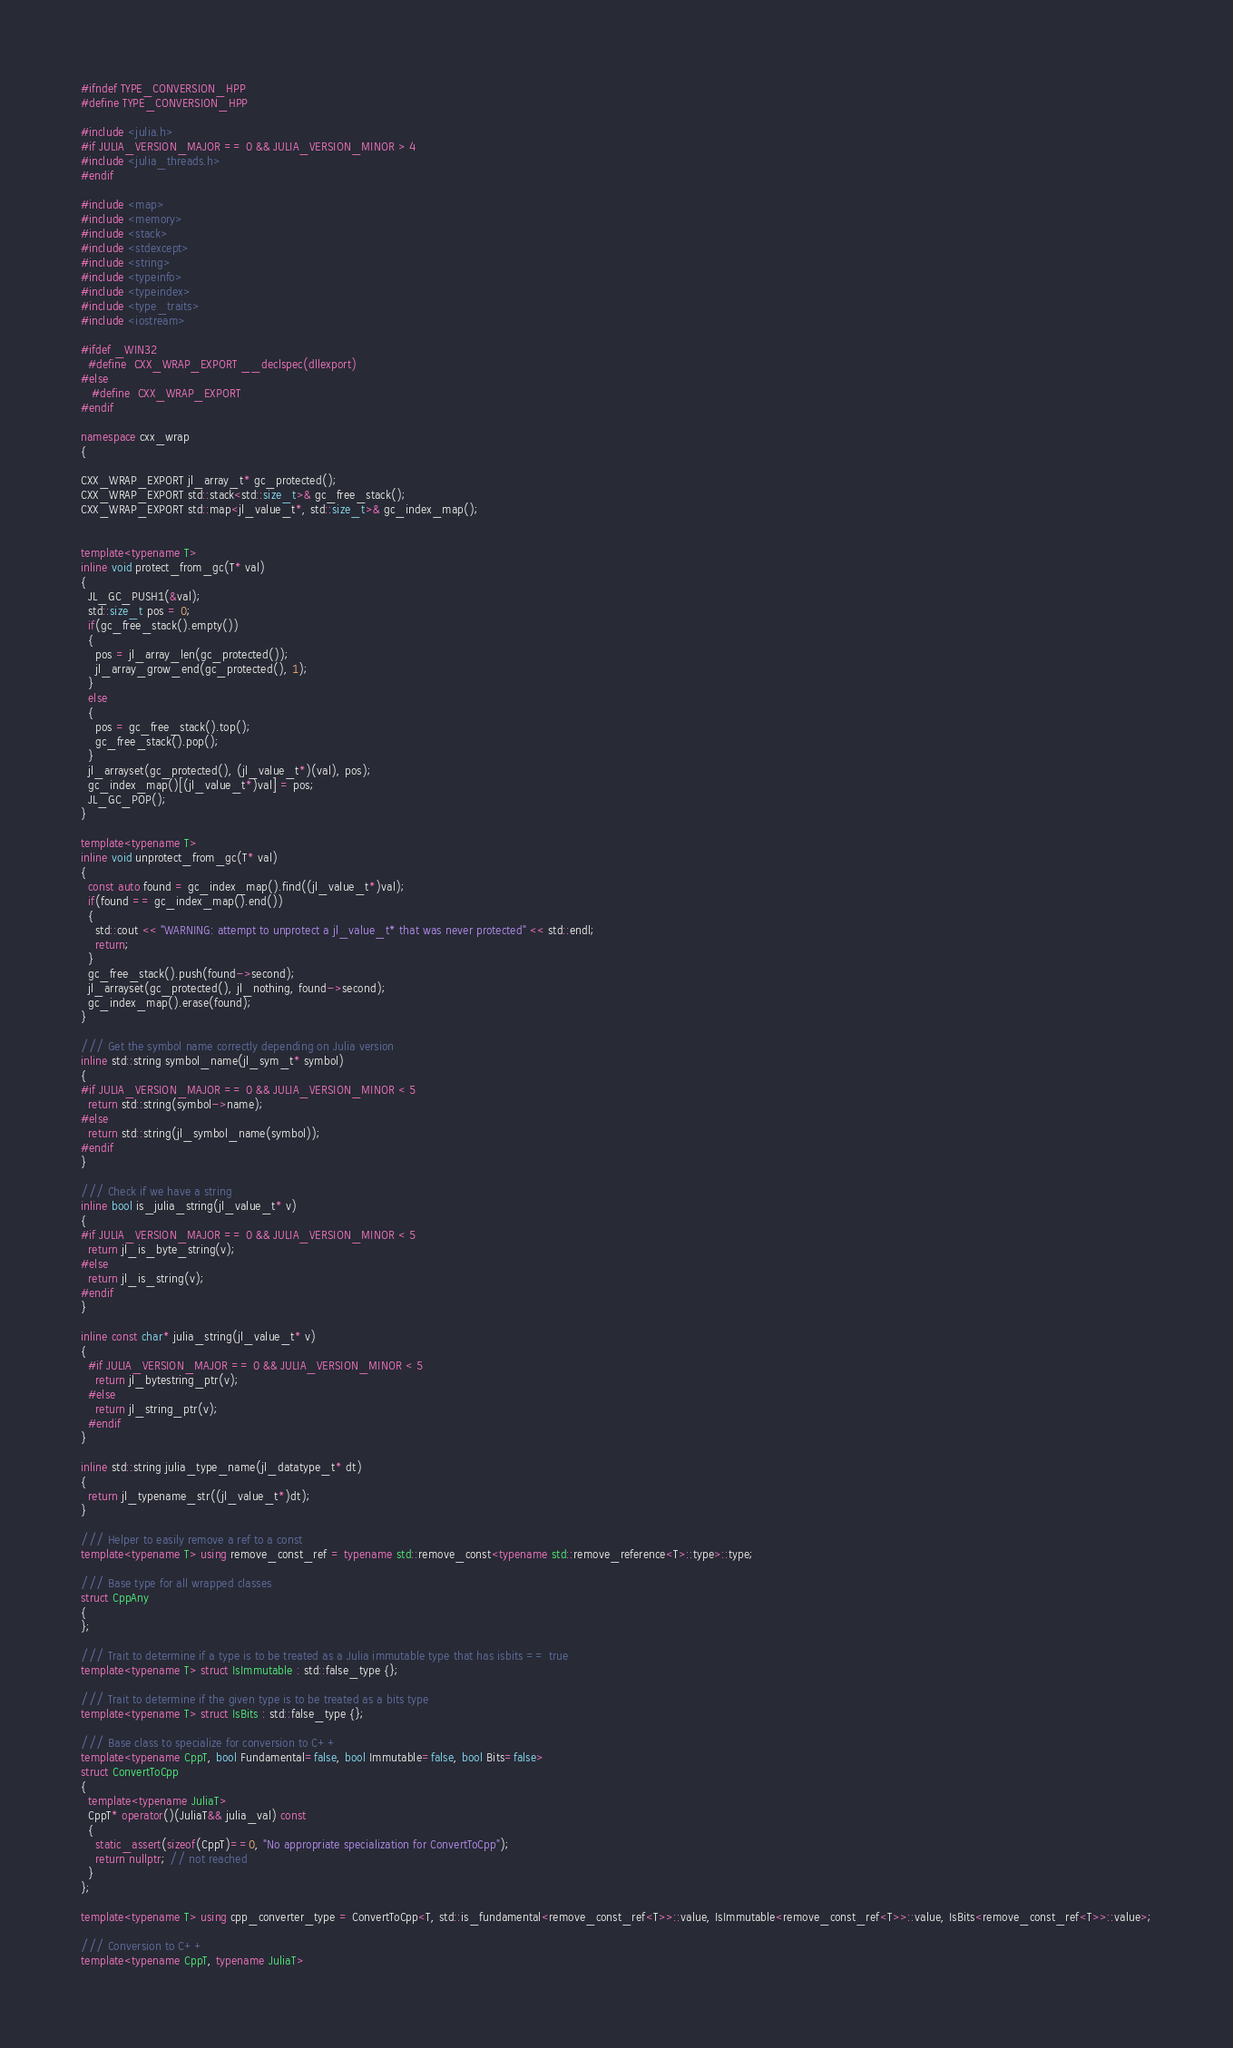Convert code to text. <code><loc_0><loc_0><loc_500><loc_500><_C++_>#ifndef TYPE_CONVERSION_HPP
#define TYPE_CONVERSION_HPP

#include <julia.h>
#if JULIA_VERSION_MAJOR == 0 && JULIA_VERSION_MINOR > 4
#include <julia_threads.h>
#endif

#include <map>
#include <memory>
#include <stack>
#include <stdexcept>
#include <string>
#include <typeinfo>
#include <typeindex>
#include <type_traits>
#include <iostream>

#ifdef _WIN32
  #define  CXX_WRAP_EXPORT __declspec(dllexport)
#else
   #define  CXX_WRAP_EXPORT
#endif

namespace cxx_wrap
{

CXX_WRAP_EXPORT jl_array_t* gc_protected();
CXX_WRAP_EXPORT std::stack<std::size_t>& gc_free_stack();
CXX_WRAP_EXPORT std::map<jl_value_t*, std::size_t>& gc_index_map();


template<typename T>
inline void protect_from_gc(T* val)
{
  JL_GC_PUSH1(&val);
  std::size_t pos = 0;
  if(gc_free_stack().empty())
  {
    pos = jl_array_len(gc_protected());
    jl_array_grow_end(gc_protected(), 1);
  }
  else
  {
    pos = gc_free_stack().top();
    gc_free_stack().pop();
  }
  jl_arrayset(gc_protected(), (jl_value_t*)(val), pos);
  gc_index_map()[(jl_value_t*)val] = pos;
  JL_GC_POP();
}

template<typename T>
inline void unprotect_from_gc(T* val)
{
  const auto found = gc_index_map().find((jl_value_t*)val);
  if(found == gc_index_map().end())
  {
    std::cout << "WARNING: attempt to unprotect a jl_value_t* that was never protected" << std::endl;
    return;
  }
  gc_free_stack().push(found->second);
  jl_arrayset(gc_protected(), jl_nothing, found->second);
  gc_index_map().erase(found);
}

/// Get the symbol name correctly depending on Julia version
inline std::string symbol_name(jl_sym_t* symbol)
{
#if JULIA_VERSION_MAJOR == 0 && JULIA_VERSION_MINOR < 5
  return std::string(symbol->name);
#else
  return std::string(jl_symbol_name(symbol));
#endif
}

/// Check if we have a string
inline bool is_julia_string(jl_value_t* v)
{
#if JULIA_VERSION_MAJOR == 0 && JULIA_VERSION_MINOR < 5
  return jl_is_byte_string(v);
#else
  return jl_is_string(v);
#endif
}

inline const char* julia_string(jl_value_t* v)
{
  #if JULIA_VERSION_MAJOR == 0 && JULIA_VERSION_MINOR < 5
    return jl_bytestring_ptr(v);
  #else
    return jl_string_ptr(v);
  #endif
}

inline std::string julia_type_name(jl_datatype_t* dt)
{
  return jl_typename_str((jl_value_t*)dt);
}

/// Helper to easily remove a ref to a const
template<typename T> using remove_const_ref = typename std::remove_const<typename std::remove_reference<T>::type>::type;

/// Base type for all wrapped classes
struct CppAny
{
};

/// Trait to determine if a type is to be treated as a Julia immutable type that has isbits == true
template<typename T> struct IsImmutable : std::false_type {};

/// Trait to determine if the given type is to be treated as a bits type
template<typename T> struct IsBits : std::false_type {};

/// Base class to specialize for conversion to C++
template<typename CppT, bool Fundamental=false, bool Immutable=false, bool Bits=false>
struct ConvertToCpp
{
  template<typename JuliaT>
  CppT* operator()(JuliaT&& julia_val) const
  {
    static_assert(sizeof(CppT)==0, "No appropriate specialization for ConvertToCpp");
    return nullptr; // not reached
  }
};

template<typename T> using cpp_converter_type = ConvertToCpp<T, std::is_fundamental<remove_const_ref<T>>::value, IsImmutable<remove_const_ref<T>>::value, IsBits<remove_const_ref<T>>::value>;

/// Conversion to C++
template<typename CppT, typename JuliaT></code> 